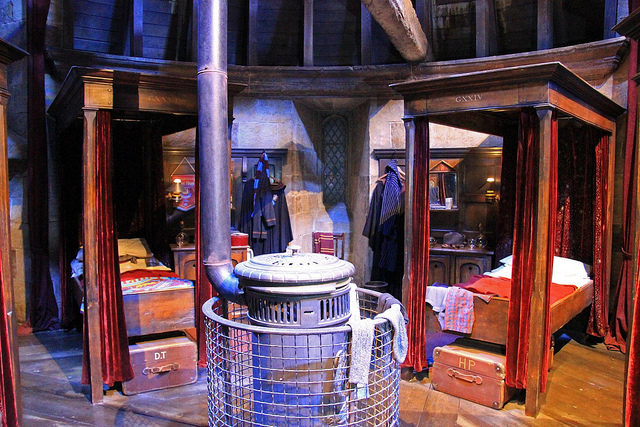What movie is this from? This image is from the Harry Potter films, showcasing a setting that resembles the Gryffindor Boys' dormitory with distinctive props like the beds and trunks labeled with the initials HP. 